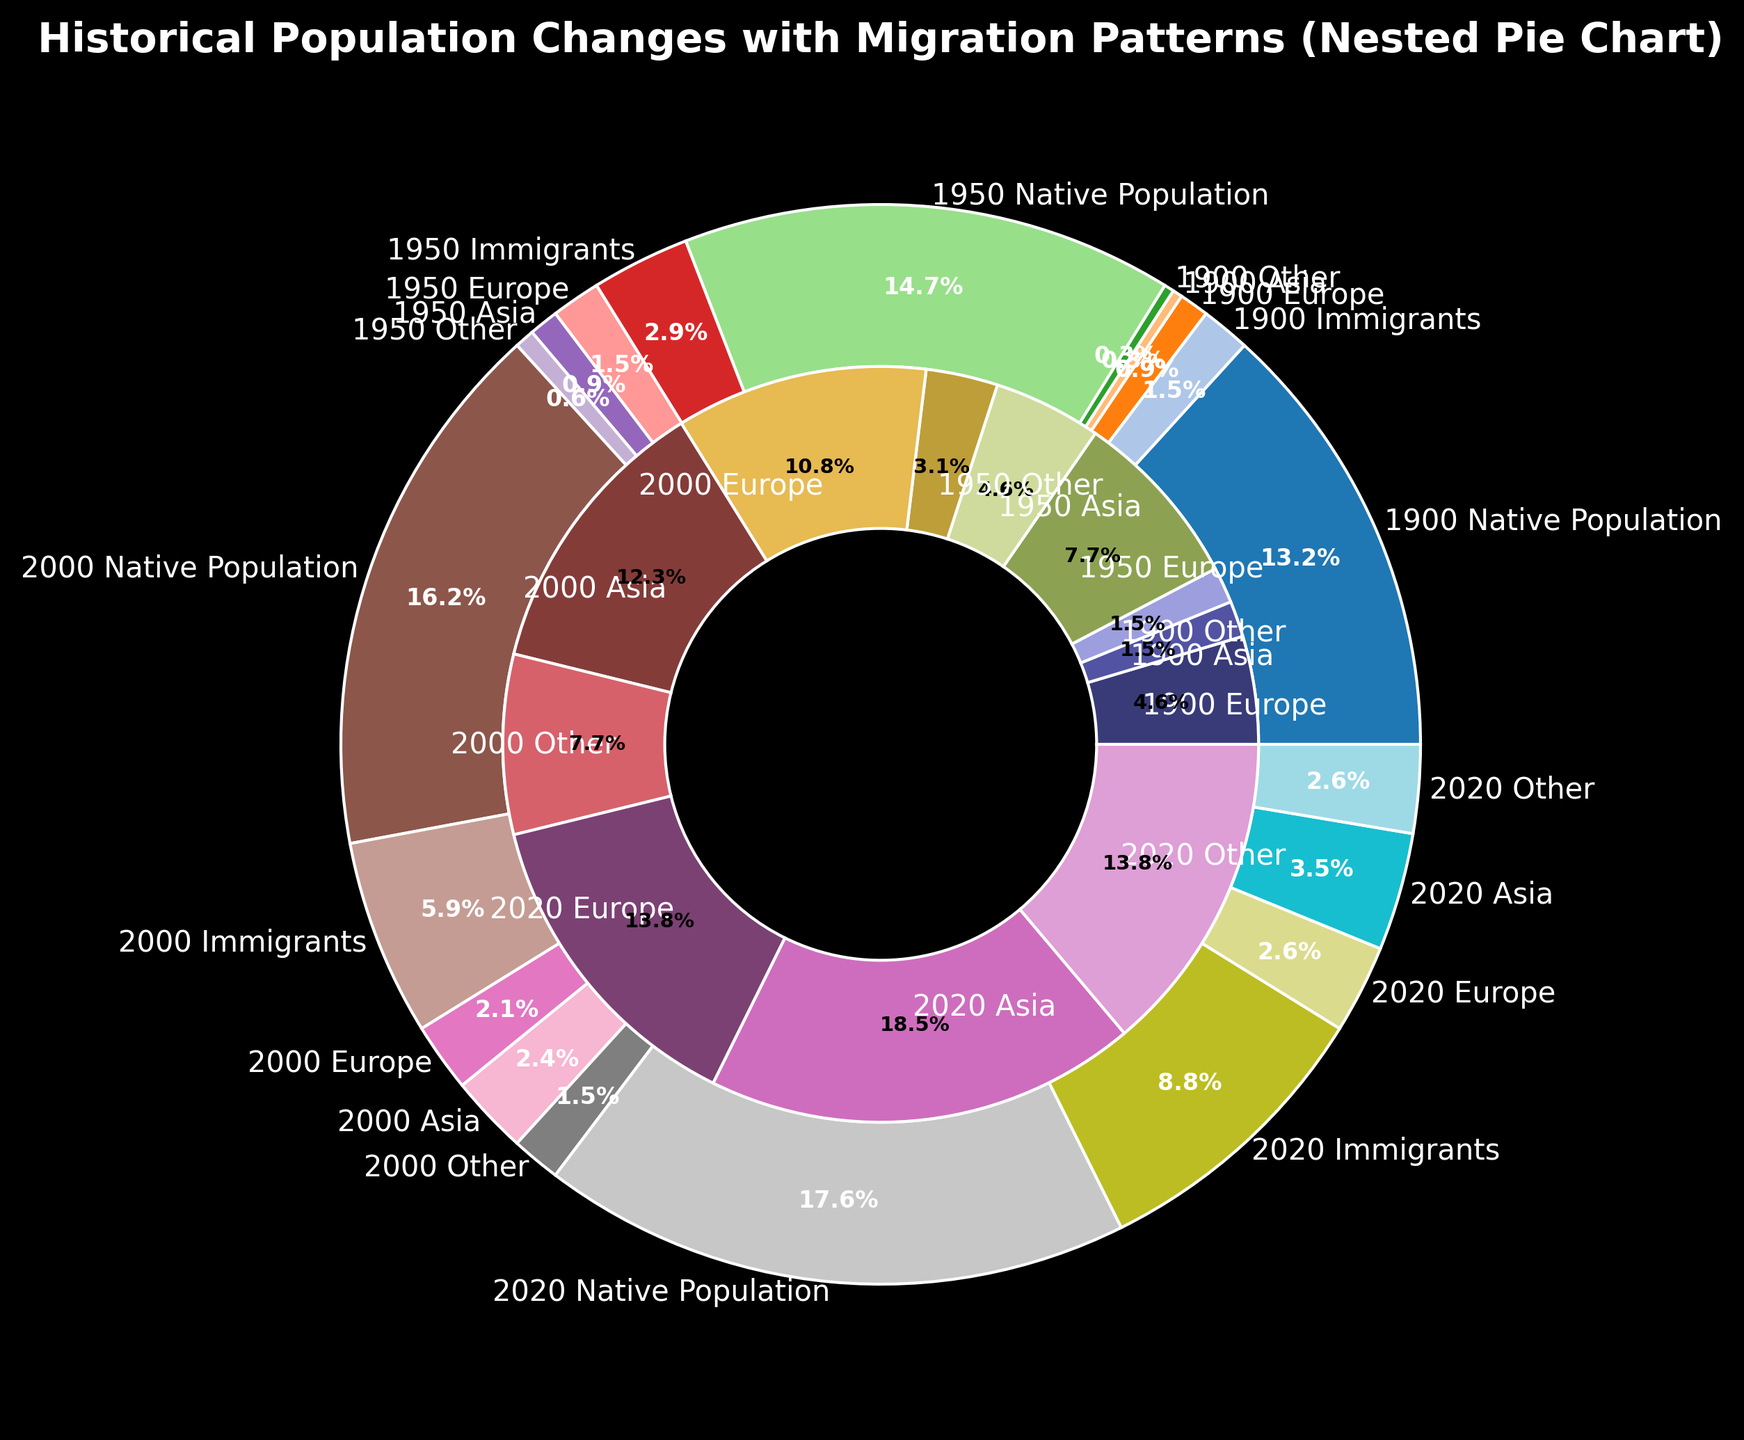What percentage of the total population in 2020 was made up of immigrants? In 2020, the native population was 60,000, and the immigrant population was 30,000. The total population is the sum of these two numbers, which is 90,000. The proportion of immigrants is calculated as (30,000 / 90,000) * 100%.
Answer: 33.3% How has the proportion of Asian immigrants changed from 1900 to 2020? In 1900, Asian immigrants were 1,000 out of a total immigrant population of 5,000, making up 20%. In 2020, Asian immigrants were 12,000 out of a total immigrant population of 30,000, making up 40%. The proportion increased from 20% to 40%.
Answer: Increased by 20% Which year had the highest population of immigrants from Europe, and what was that population? Referring to the nested pie slices labeled for each year for European immigrants: 3,000 for 1900, 5,000 for 1950, 7,000 for 2000, and 9,000 for 2020. The year with the highest population of European immigrants is 2020.
Answer: 2020, 9,000 How did the total population change from 1900 to 2020? In 1900, the total population was 45,000 native plus 5,000 immigrants, totaling 50,000. In 2020, it was 60,000 native plus 30,000 immigrants, totaling 90,000. The change is calculated as 90,000 - 50,000.
Answer: Increased by 40,000 What is the total population of immigrants for all years combined? Sum the immigrant populations for all years: 5,000 (1900) + 10,000 (1950) + 20,000 (2000) + 30,000 (2020).
Answer: 65,000 In which year did the total 'Other' category of immigrants first exceed 2,000? Checking each year: 'Other' immigrants are 1,000 in 1900, 2,000 in 1950, 5,000 in 2000, and 9,000 in 2020. 2000 is the first year it exceeds 2,000.
Answer: 2000 Compare the native population growth from 1900 to 2020 with the immigrant population growth from 1900 to 2020. Native population grew from 45,000 in 1900 to 60,000 in 2020, an increase of 15,000. Immigrant population grew from 5,000 in 1900 to 30,000 in 2020, an increase of 25,000. Immigrant population growth was larger.
Answer: Immigrant growth: 25,000, Native growth: 15,000 What was the proportion of the total population made up of European immigrants in 2000? In 2000, European immigrants were 7,000 out of a total population of 55,000 native plus 20,000 immigrants, which totals 75,000. The proportion is (7,000 / 75,000) * 100%.
Answer: 9.3% Comparing 1900 and 1950, in which year did 'Other' immigrants constitute a larger proportion of the total immigrant population? In 1900, 'Other' immigrants were 1,000 out of 5,000 immigrants (20%). In 1950, 'Other' immigrants were 2,000 out of 10,000 immigrants (20%). The proportions are equal.
Answer: They are equal, 20% Which category of immigrants saw the greatest increase in numbers from 1950 to 2020? Comparing the immigrant numbers in 1950 and 2020: Europe (5,000 to 9,000: increase of 4,000), Asia (3,000 to 12,000: increase of 9,000), Other (2,000 to 9,000: increase of 7,000). The greatest increase is in Asian immigrants.
Answer: Asia, increase of 9,000 